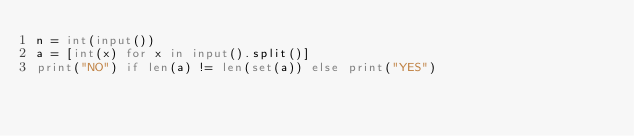Convert code to text. <code><loc_0><loc_0><loc_500><loc_500><_Python_>n = int(input())
a = [int(x) for x in input().split()]
print("NO") if len(a) != len(set(a)) else print("YES")</code> 